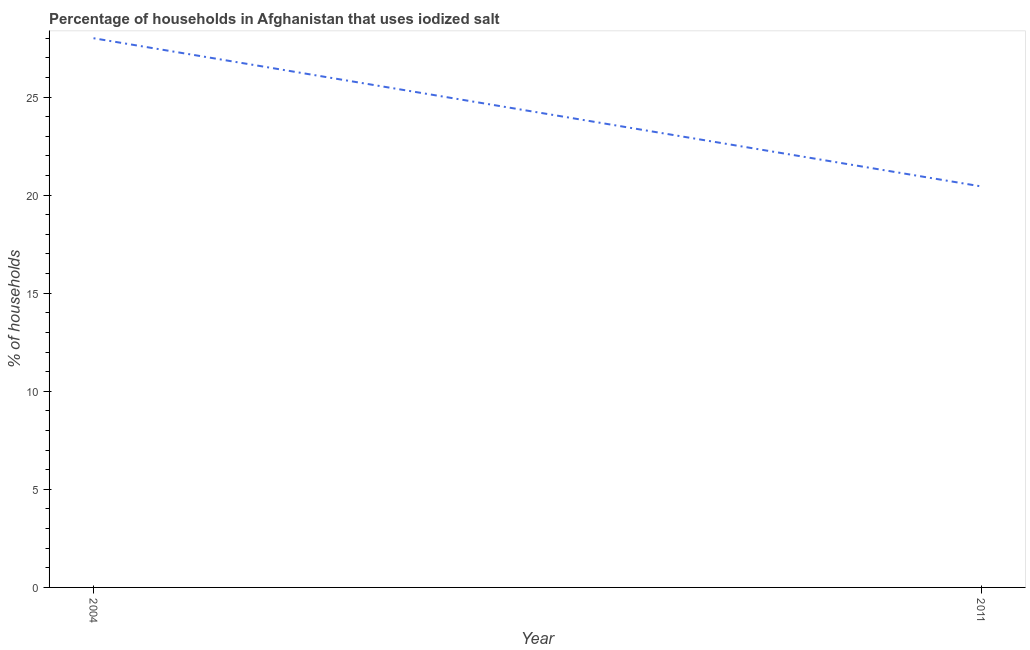What is the percentage of households where iodized salt is consumed in 2011?
Offer a very short reply. 20.45. Across all years, what is the maximum percentage of households where iodized salt is consumed?
Offer a terse response. 28. Across all years, what is the minimum percentage of households where iodized salt is consumed?
Offer a very short reply. 20.45. What is the sum of the percentage of households where iodized salt is consumed?
Make the answer very short. 48.45. What is the difference between the percentage of households where iodized salt is consumed in 2004 and 2011?
Your answer should be compact. 7.55. What is the average percentage of households where iodized salt is consumed per year?
Offer a terse response. 24.22. What is the median percentage of households where iodized salt is consumed?
Give a very brief answer. 24.22. What is the ratio of the percentage of households where iodized salt is consumed in 2004 to that in 2011?
Keep it short and to the point. 1.37. In how many years, is the percentage of households where iodized salt is consumed greater than the average percentage of households where iodized salt is consumed taken over all years?
Provide a succinct answer. 1. Does the percentage of households where iodized salt is consumed monotonically increase over the years?
Make the answer very short. No. How many lines are there?
Offer a terse response. 1. Are the values on the major ticks of Y-axis written in scientific E-notation?
Offer a very short reply. No. Does the graph contain grids?
Provide a short and direct response. No. What is the title of the graph?
Provide a short and direct response. Percentage of households in Afghanistan that uses iodized salt. What is the label or title of the Y-axis?
Provide a short and direct response. % of households. What is the % of households of 2004?
Ensure brevity in your answer.  28. What is the % of households of 2011?
Offer a terse response. 20.45. What is the difference between the % of households in 2004 and 2011?
Make the answer very short. 7.55. What is the ratio of the % of households in 2004 to that in 2011?
Provide a short and direct response. 1.37. 